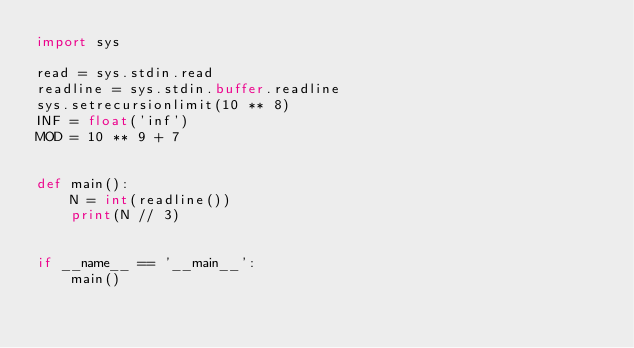Convert code to text. <code><loc_0><loc_0><loc_500><loc_500><_Python_>import sys

read = sys.stdin.read
readline = sys.stdin.buffer.readline
sys.setrecursionlimit(10 ** 8)
INF = float('inf')
MOD = 10 ** 9 + 7


def main():
    N = int(readline())
    print(N // 3)


if __name__ == '__main__':
    main()
</code> 